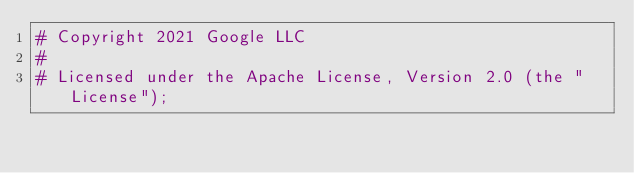Convert code to text. <code><loc_0><loc_0><loc_500><loc_500><_YAML_># Copyright 2021 Google LLC
#
# Licensed under the Apache License, Version 2.0 (the "License");</code> 